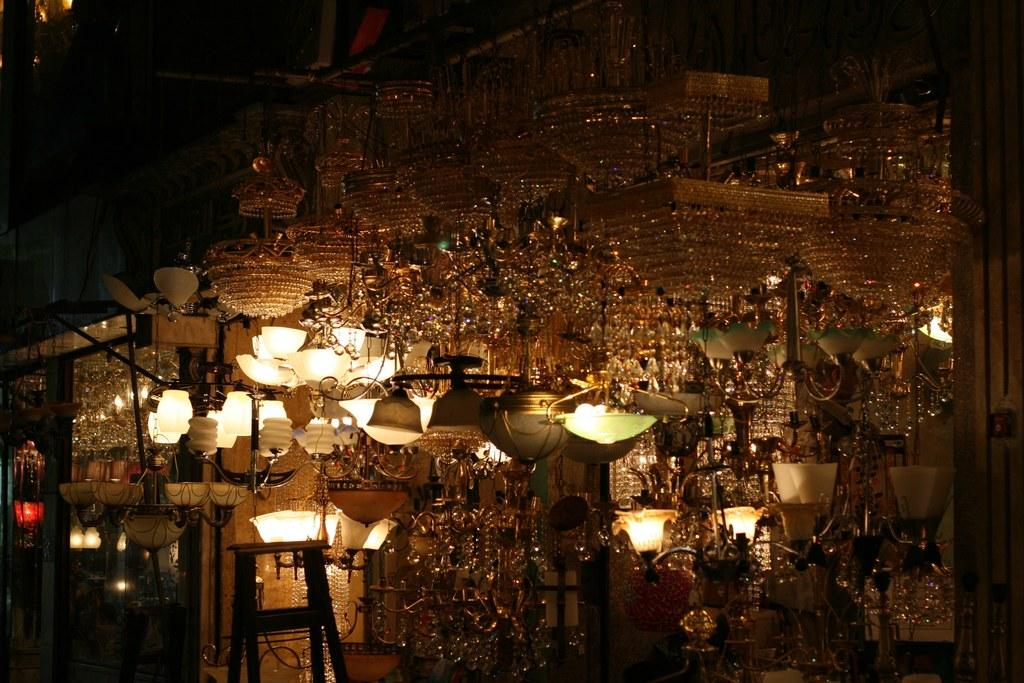What is hanging from the ceiling in the image? There are lights hanging from the ceiling in the image. What type of ladder can be seen in the image? There is a double-sided ladder in the image. What type of dogs are present in the image? There are no dogs present in the image. What meal is being prepared on the ladder in the image? There is no meal being prepared in the image, and the ladder is not being used for cooking purposes. 